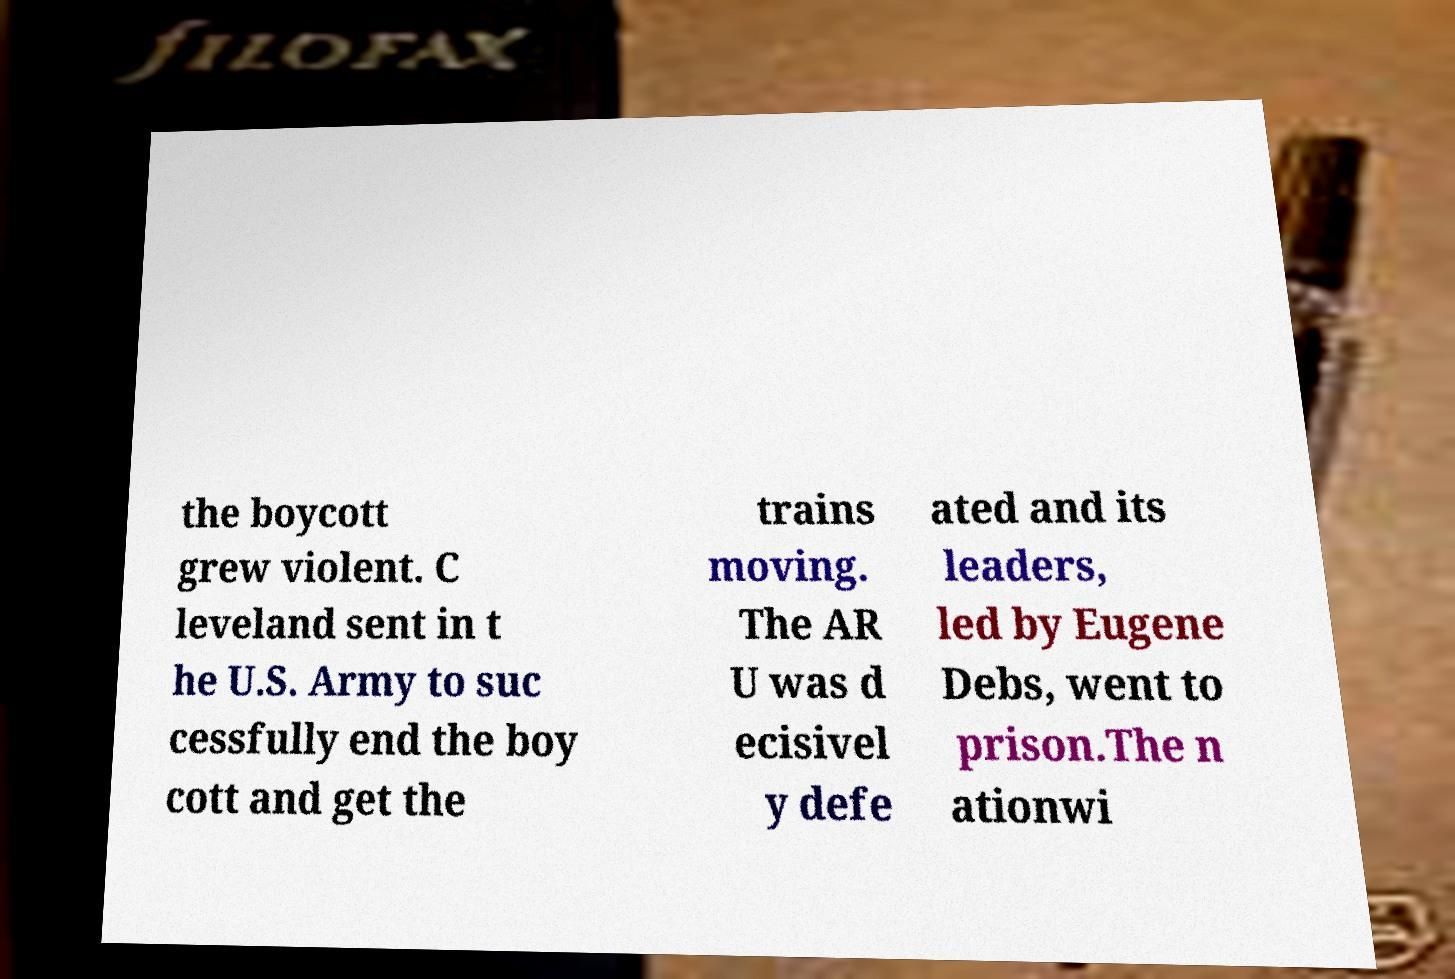I need the written content from this picture converted into text. Can you do that? the boycott grew violent. C leveland sent in t he U.S. Army to suc cessfully end the boy cott and get the trains moving. The AR U was d ecisivel y defe ated and its leaders, led by Eugene Debs, went to prison.The n ationwi 